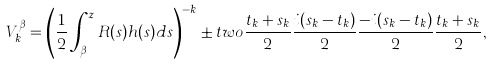<formula> <loc_0><loc_0><loc_500><loc_500>V _ { k } ^ { \beta } & = \left ( \frac { 1 } { 2 } \int _ { \beta } ^ { z } R ( s ) h ( s ) d s \right ) ^ { - k } \pm t w o { \frac { t _ { k } + s _ { k } } { 2 } } { \frac { i ( s _ { k } - t _ { k } ) } { 2 } } { \frac { - i ( s _ { k } - t _ { k } ) } { 2 } } { \frac { t _ { k } + s _ { k } } { 2 } } ,</formula> 